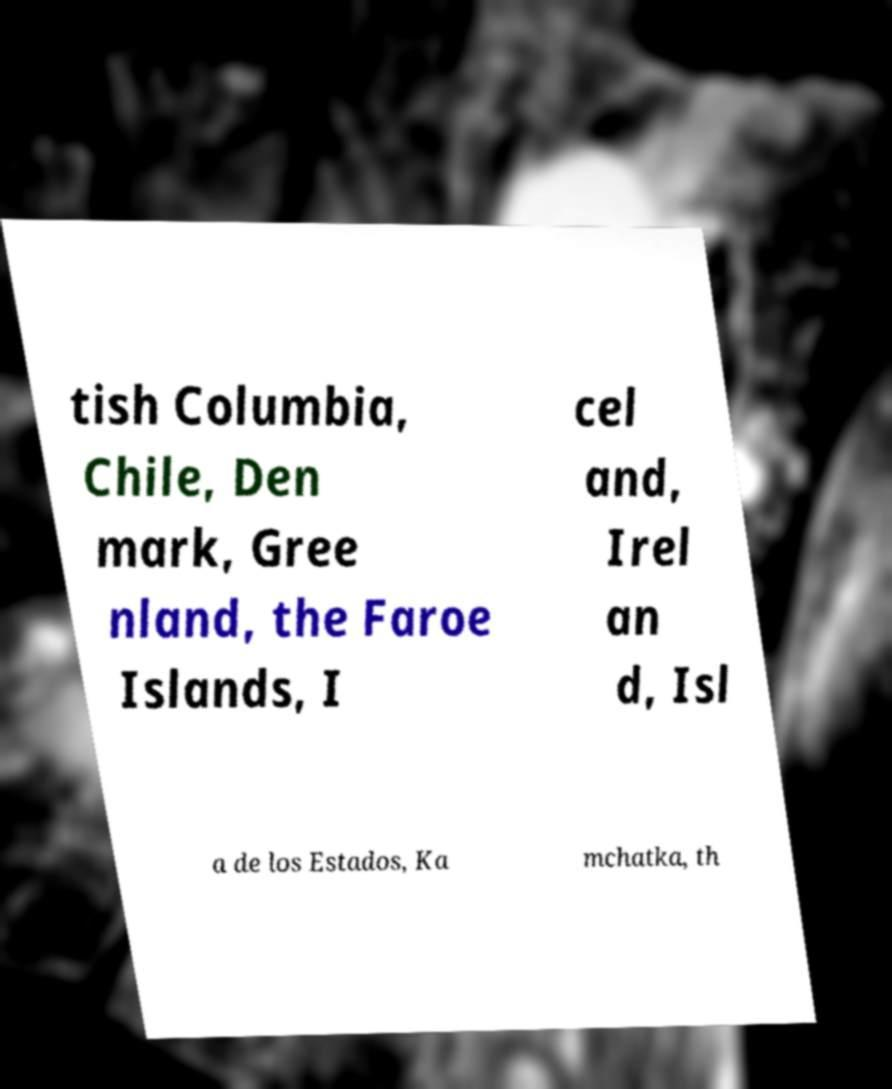There's text embedded in this image that I need extracted. Can you transcribe it verbatim? tish Columbia, Chile, Den mark, Gree nland, the Faroe Islands, I cel and, Irel an d, Isl a de los Estados, Ka mchatka, th 